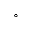<formula> <loc_0><loc_0><loc_500><loc_500>^ { \circ }</formula> 